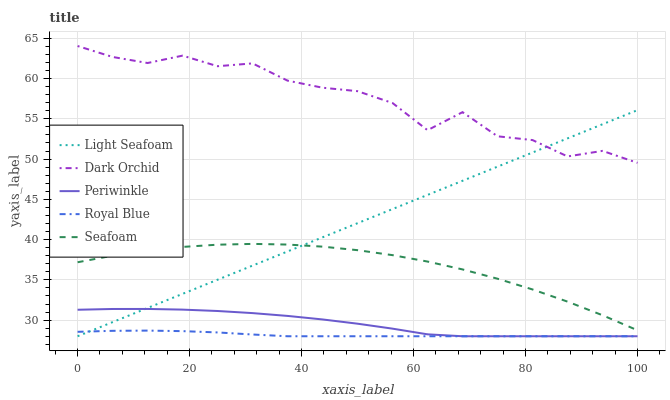Does Royal Blue have the minimum area under the curve?
Answer yes or no. Yes. Does Dark Orchid have the maximum area under the curve?
Answer yes or no. Yes. Does Light Seafoam have the minimum area under the curve?
Answer yes or no. No. Does Light Seafoam have the maximum area under the curve?
Answer yes or no. No. Is Light Seafoam the smoothest?
Answer yes or no. Yes. Is Dark Orchid the roughest?
Answer yes or no. Yes. Is Periwinkle the smoothest?
Answer yes or no. No. Is Periwinkle the roughest?
Answer yes or no. No. Does Royal Blue have the lowest value?
Answer yes or no. Yes. Does Seafoam have the lowest value?
Answer yes or no. No. Does Dark Orchid have the highest value?
Answer yes or no. Yes. Does Light Seafoam have the highest value?
Answer yes or no. No. Is Periwinkle less than Dark Orchid?
Answer yes or no. Yes. Is Dark Orchid greater than Royal Blue?
Answer yes or no. Yes. Does Royal Blue intersect Periwinkle?
Answer yes or no. Yes. Is Royal Blue less than Periwinkle?
Answer yes or no. No. Is Royal Blue greater than Periwinkle?
Answer yes or no. No. Does Periwinkle intersect Dark Orchid?
Answer yes or no. No. 